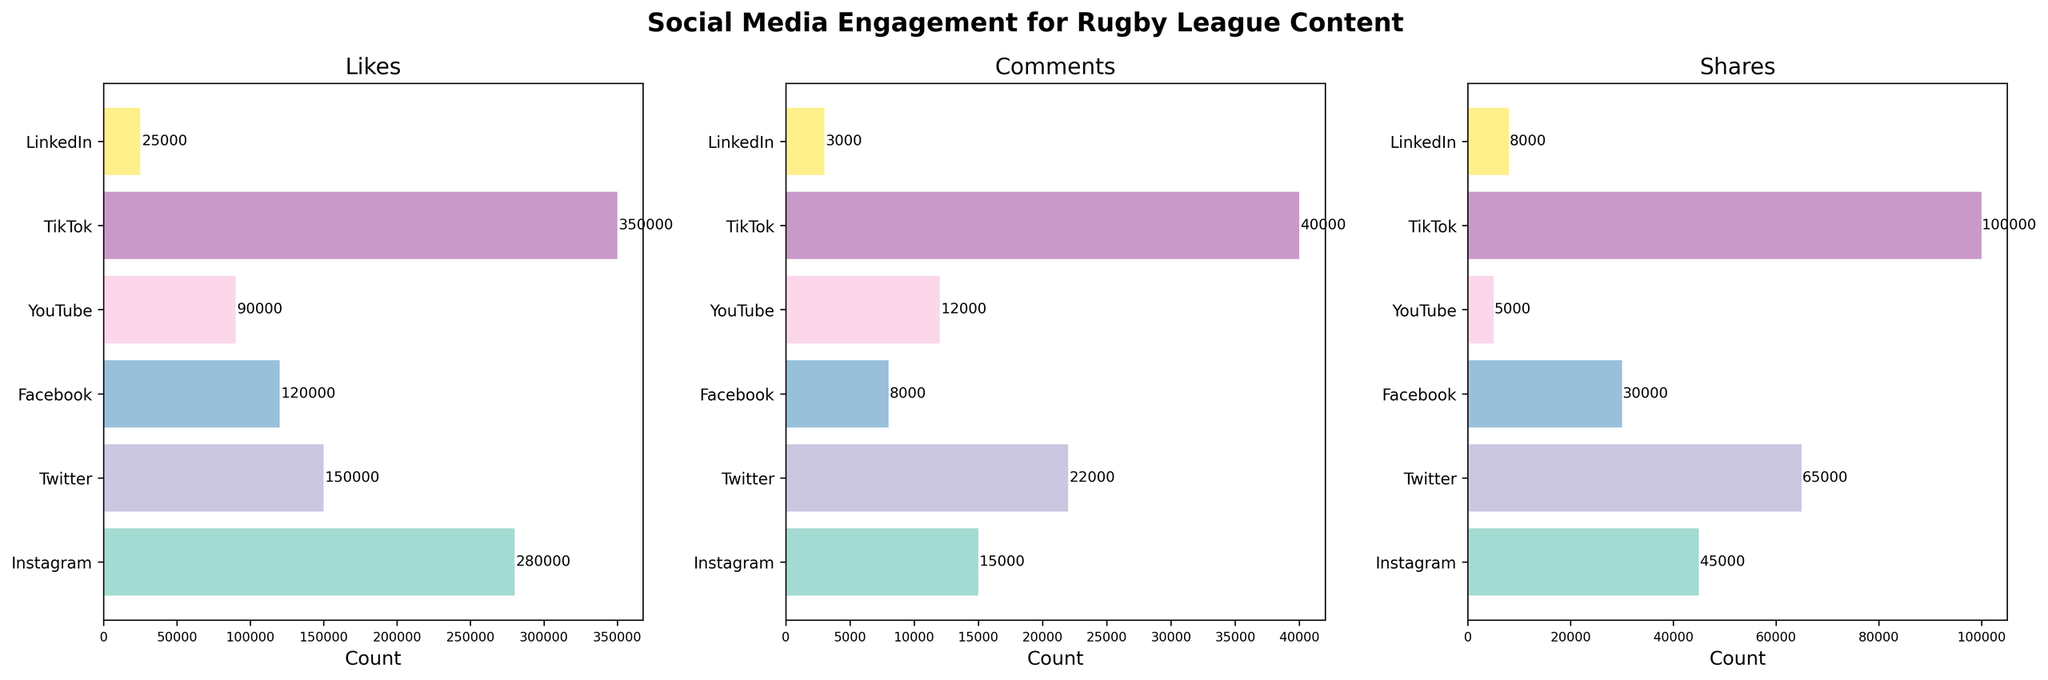What is the title of the figure? The title is displayed prominently at the top of the figure, which reads "Social Media Engagement for Rugby League Content".
Answer: Social Media Engagement for Rugby League Content Which platform has the highest number of likes? Reviewing the 'Likes' subplot, TikTok has the highest bar with a value of 350,000 likes.
Answer: TikTok How many comments did Facebook receive? In the 'Comments' subplot, the bar for Facebook extends to 8,000 comments, which is also labeled at the end of the bar.
Answer: 8,000 Which platform has nearly half the number of likes compared to the platform with the highest likes? The platform with the highest likes is TikTok at 350,000. Instagram has 280,000 likes, which is approximately 80,000 less than half of TikTok's likes. After comparing values, YouTube with 90,000 likes is close to half of Instagram's likes.
Answer: YouTube On which platform were the shares slightly higher than the comments but far fewer than the likes? From the 'Shares' subplot, on Facebook, shares are 30,000, which is slightly higher than comments (8,000) and significantly fewer than likes (120,000).
Answer: Facebook Rank the platforms based on the number of comments they received, from highest to lowest. Reviewing the 'Comments' subplot: TikTok (40,000), Twitter (22,000), YouTube (12,000), Instagram (15,000), Facebook (8,000), LinkedIn (3,000). Arranging them in descending order of comments received: TikTok, Twitter, Instagram, YouTube, Facebook, LinkedIn.
Answer: TikTok, Twitter, Instagram, YouTube, Facebook, LinkedIn Which platform received the least engagement in terms of shares? Observing the 'Shares' subplot, YouTube has the shortest bar for shares with a value of 5,000.
Answer: YouTube What is the sum of likes received across all platforms? Summing up the values from the 'Likes' subplot: 280,000 (Instagram) + 150,000 (Twitter) + 120,000 (Facebook) + 90,000 (YouTube) + 350,000 (TikTok) + 25,000 (LinkedIn) results in 1,015,000 likes.
Answer: 1,015,000 Which platform shows a significant difference in the number of comments and shares compared to likes? Noting significant differences across plots: TikTok shows a high number of comments (40,000) and shares (100,000) compared to likes (350,000), further affirming high engagement disparity across metrics.
Answer: TikTok What is the average number of likes per platform? Calculating the average likes from the total likes: 1,015,000 likes across 6 platforms results in an average of 1,015,000 / 6 = approximately 169,167 likes.
Answer: 169,167 